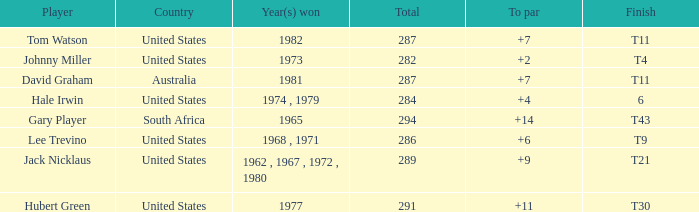WHAT IS THE TOTAL, OF A TO PAR FOR HUBERT GREEN, AND A TOTAL LARGER THAN 291? 0.0. 